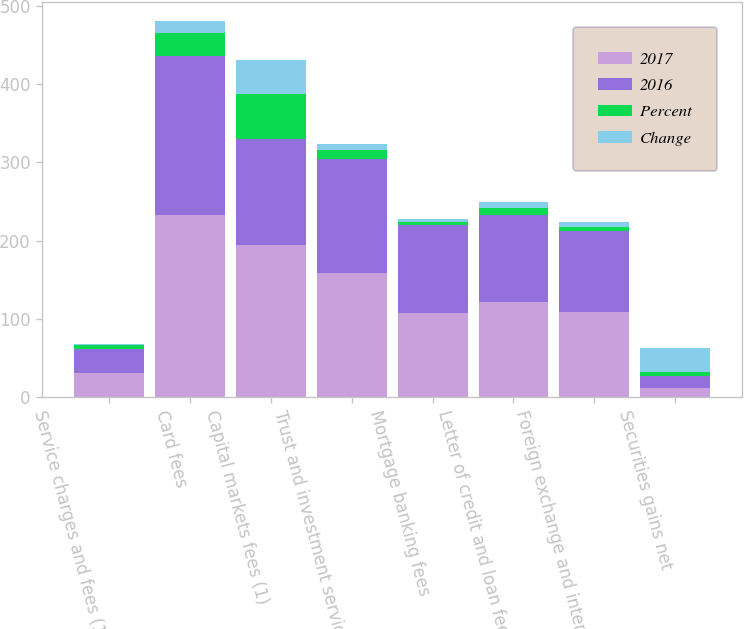Convert chart to OTSL. <chart><loc_0><loc_0><loc_500><loc_500><stacked_bar_chart><ecel><fcel>Service charges and fees (1)<fcel>Card fees<fcel>Capital markets fees (1)<fcel>Trust and investment services<fcel>Mortgage banking fees<fcel>Letter of credit and loan fees<fcel>Foreign exchange and interest<fcel>Securities gains net<nl><fcel>2017<fcel>30.5<fcel>233<fcel>194<fcel>158<fcel>108<fcel>121<fcel>109<fcel>11<nl><fcel>2016<fcel>30.5<fcel>203<fcel>136<fcel>146<fcel>112<fcel>112<fcel>103<fcel>16<nl><fcel>Percent<fcel>6<fcel>30<fcel>58<fcel>12<fcel>4<fcel>9<fcel>6<fcel>5<nl><fcel>Change<fcel>1<fcel>15<fcel>43<fcel>8<fcel>4<fcel>8<fcel>6<fcel>31<nl></chart> 